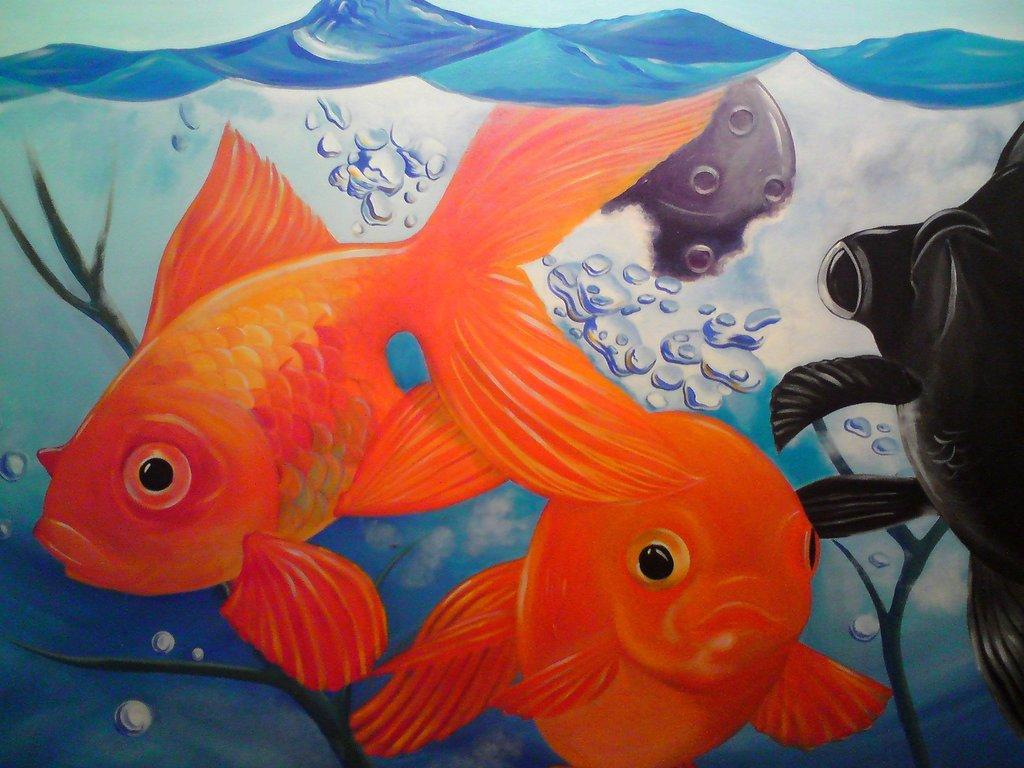What is the main subject in the center of the image? There is a poster in the center of the image. What is depicted on the poster? The poster features fish. What type of door can be seen in the image? There is no door present in the image; it only features a poster with fish. How many loaves of bread are visible in the image? There are no loaves of bread present in the image; it only features a poster with fish. 